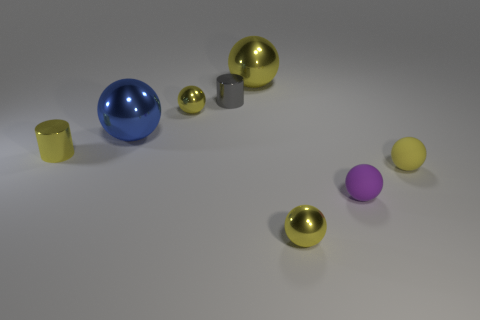How many yellow spheres must be subtracted to get 1 yellow spheres? 3 Subtract all small matte balls. How many balls are left? 4 Subtract all blue cylinders. How many yellow balls are left? 4 Subtract all blue spheres. How many spheres are left? 5 Subtract 2 spheres. How many spheres are left? 4 Subtract all gray spheres. Subtract all yellow blocks. How many spheres are left? 6 Add 2 green metal things. How many objects exist? 10 Subtract all cylinders. How many objects are left? 6 Add 4 purple spheres. How many purple spheres are left? 5 Add 3 tiny purple rubber objects. How many tiny purple rubber objects exist? 4 